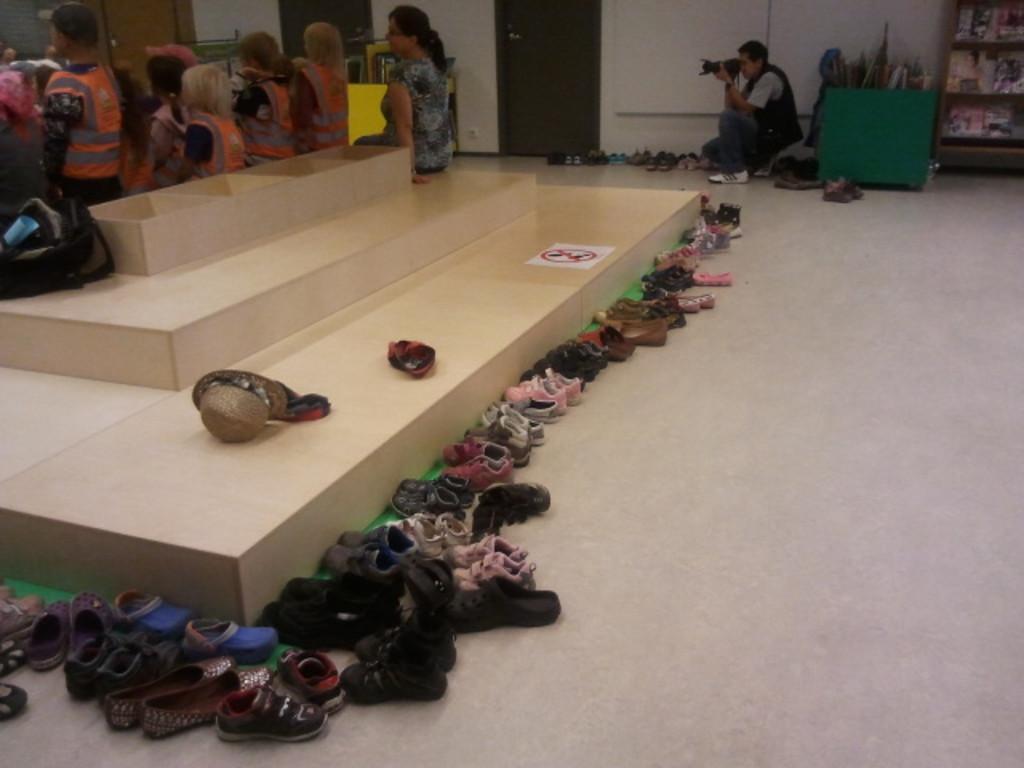Can you describe this image briefly? In this image we can see footwear placed on the floor. In the background there are persons sitting on the floor and one of them is holding camera in the hands. 